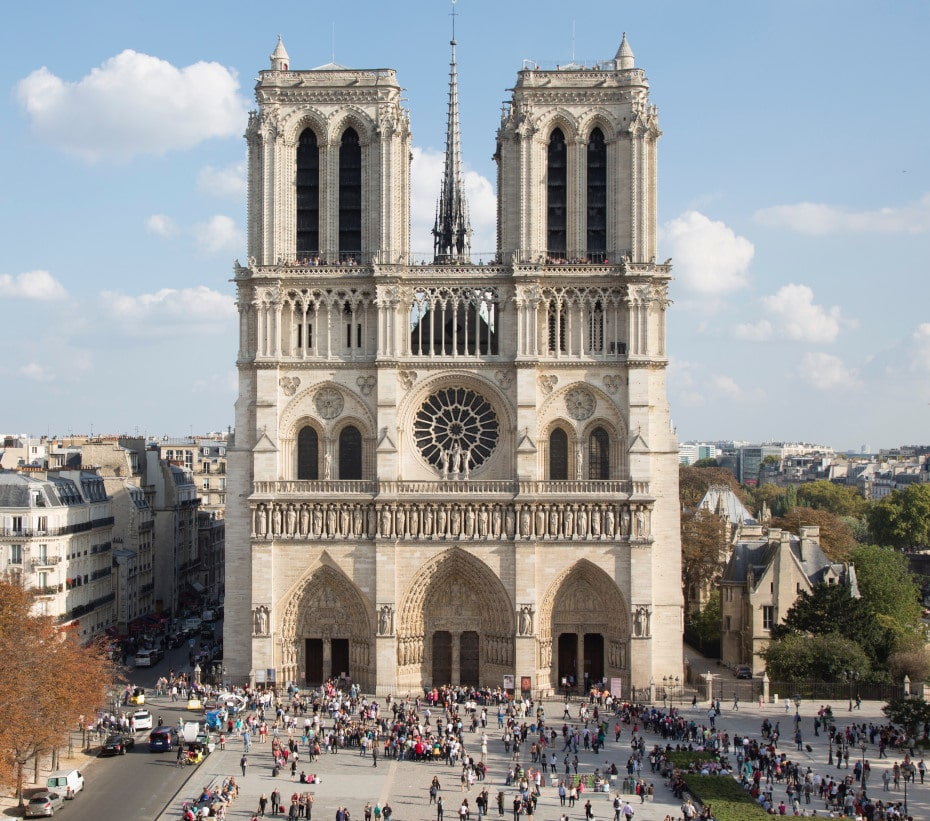How do the architectural elements of Notre Dame represent Gothic architecture? The architectural elements of Notre Dame Cathedral exemplify classic Gothic architecture through features such as its pointed arches, ribbed vaults, and flying buttresses. The verticality of its design is emphasized by the tall, narrow windows and spires which draw the eye upward, a hallmark intended to lift the spirit towards the divine. The facade's balanced, symmetrical layout with its trio of portals adorned with Gothic sculptures and the rose window above central portal, provides not just structural but also aesthetic balance, symbolizing the harmony and interconnectedness of everything under heaven. 